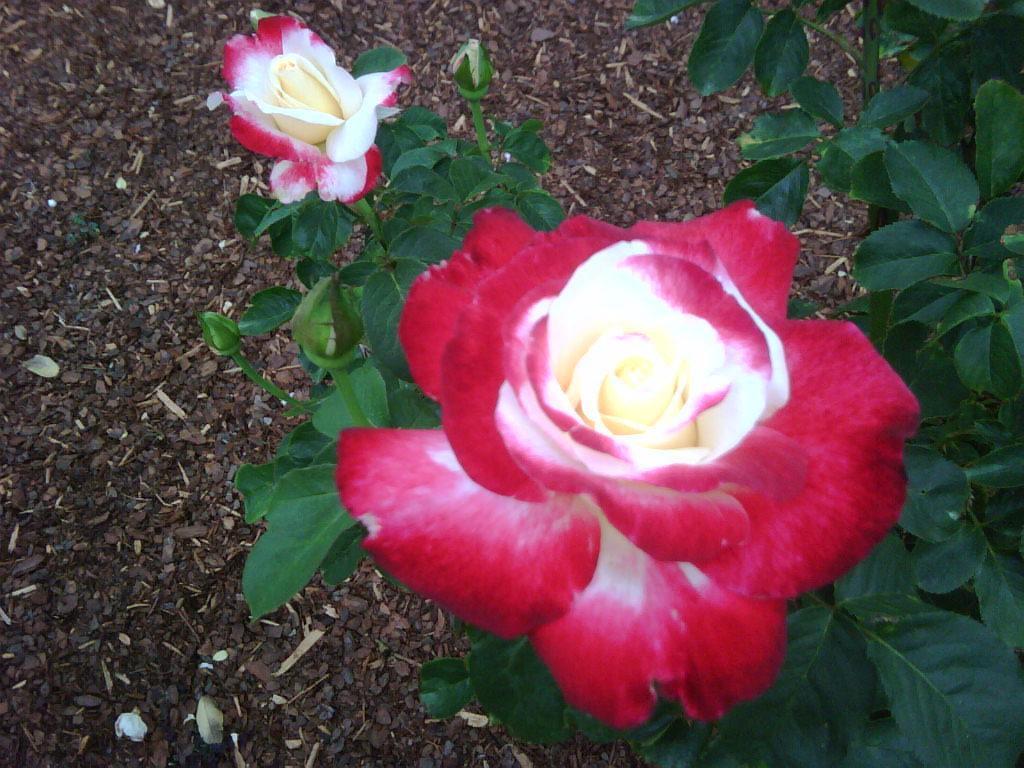In one or two sentences, can you explain what this image depicts? In this image there is a plant with two flowers, and in the background there is soil. 